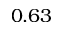Convert formula to latex. <formula><loc_0><loc_0><loc_500><loc_500>0 . 6 3</formula> 